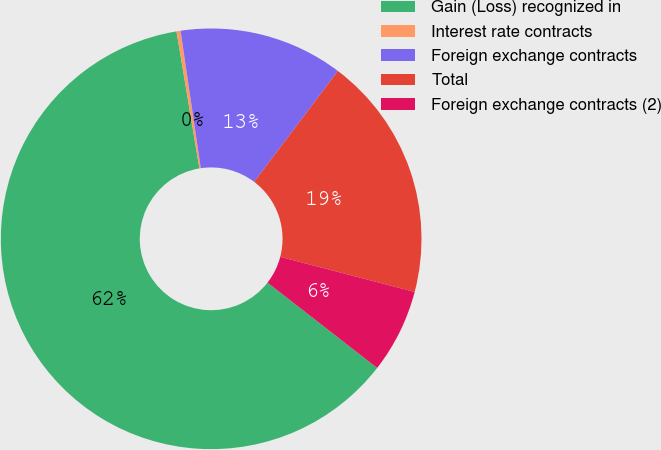<chart> <loc_0><loc_0><loc_500><loc_500><pie_chart><fcel>Gain (Loss) recognized in<fcel>Interest rate contracts<fcel>Foreign exchange contracts<fcel>Total<fcel>Foreign exchange contracts (2)<nl><fcel>61.85%<fcel>0.31%<fcel>12.62%<fcel>18.77%<fcel>6.46%<nl></chart> 